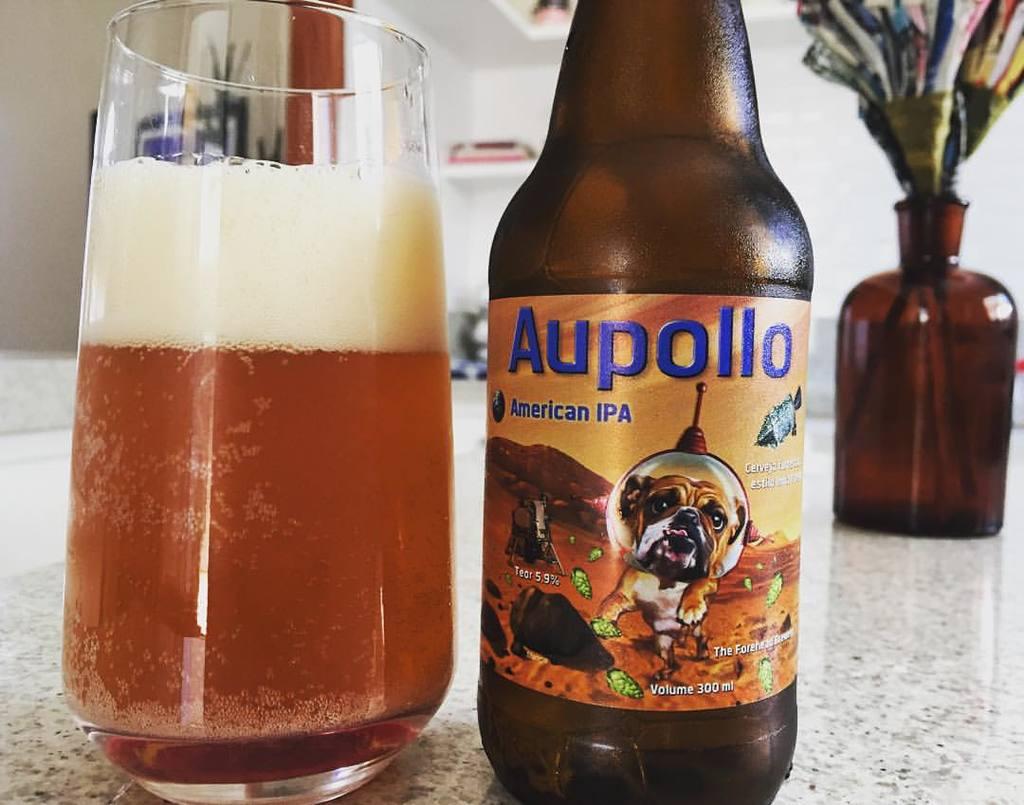Is aupollo an american ipa?
Your answer should be very brief. Yes. What kind of beer is aupollo?
Ensure brevity in your answer.  American ipa. 